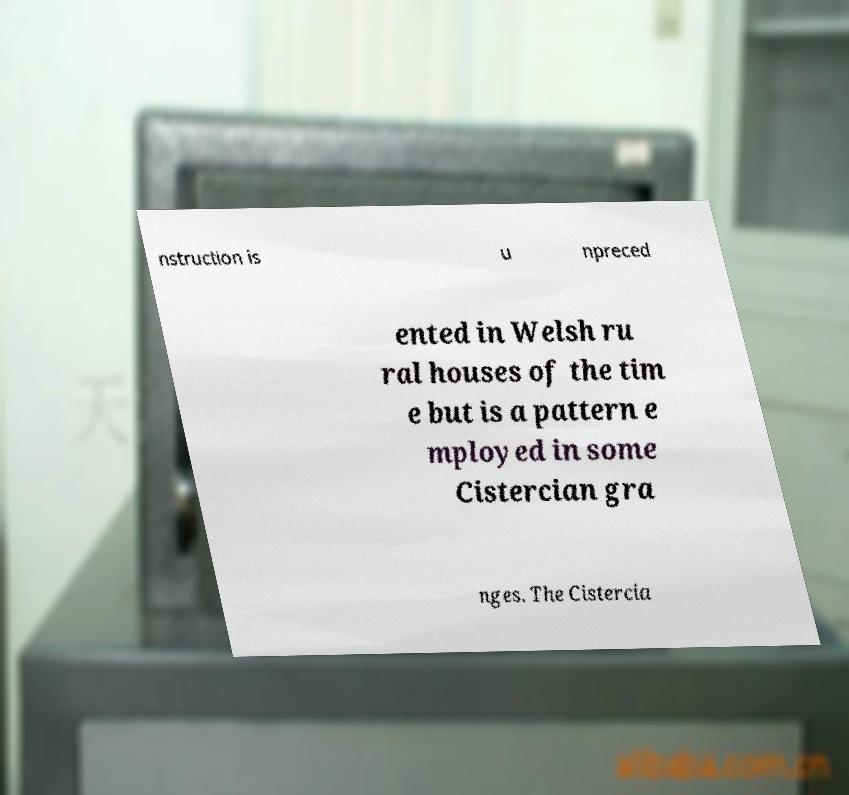I need the written content from this picture converted into text. Can you do that? nstruction is u npreced ented in Welsh ru ral houses of the tim e but is a pattern e mployed in some Cistercian gra nges. The Cistercia 